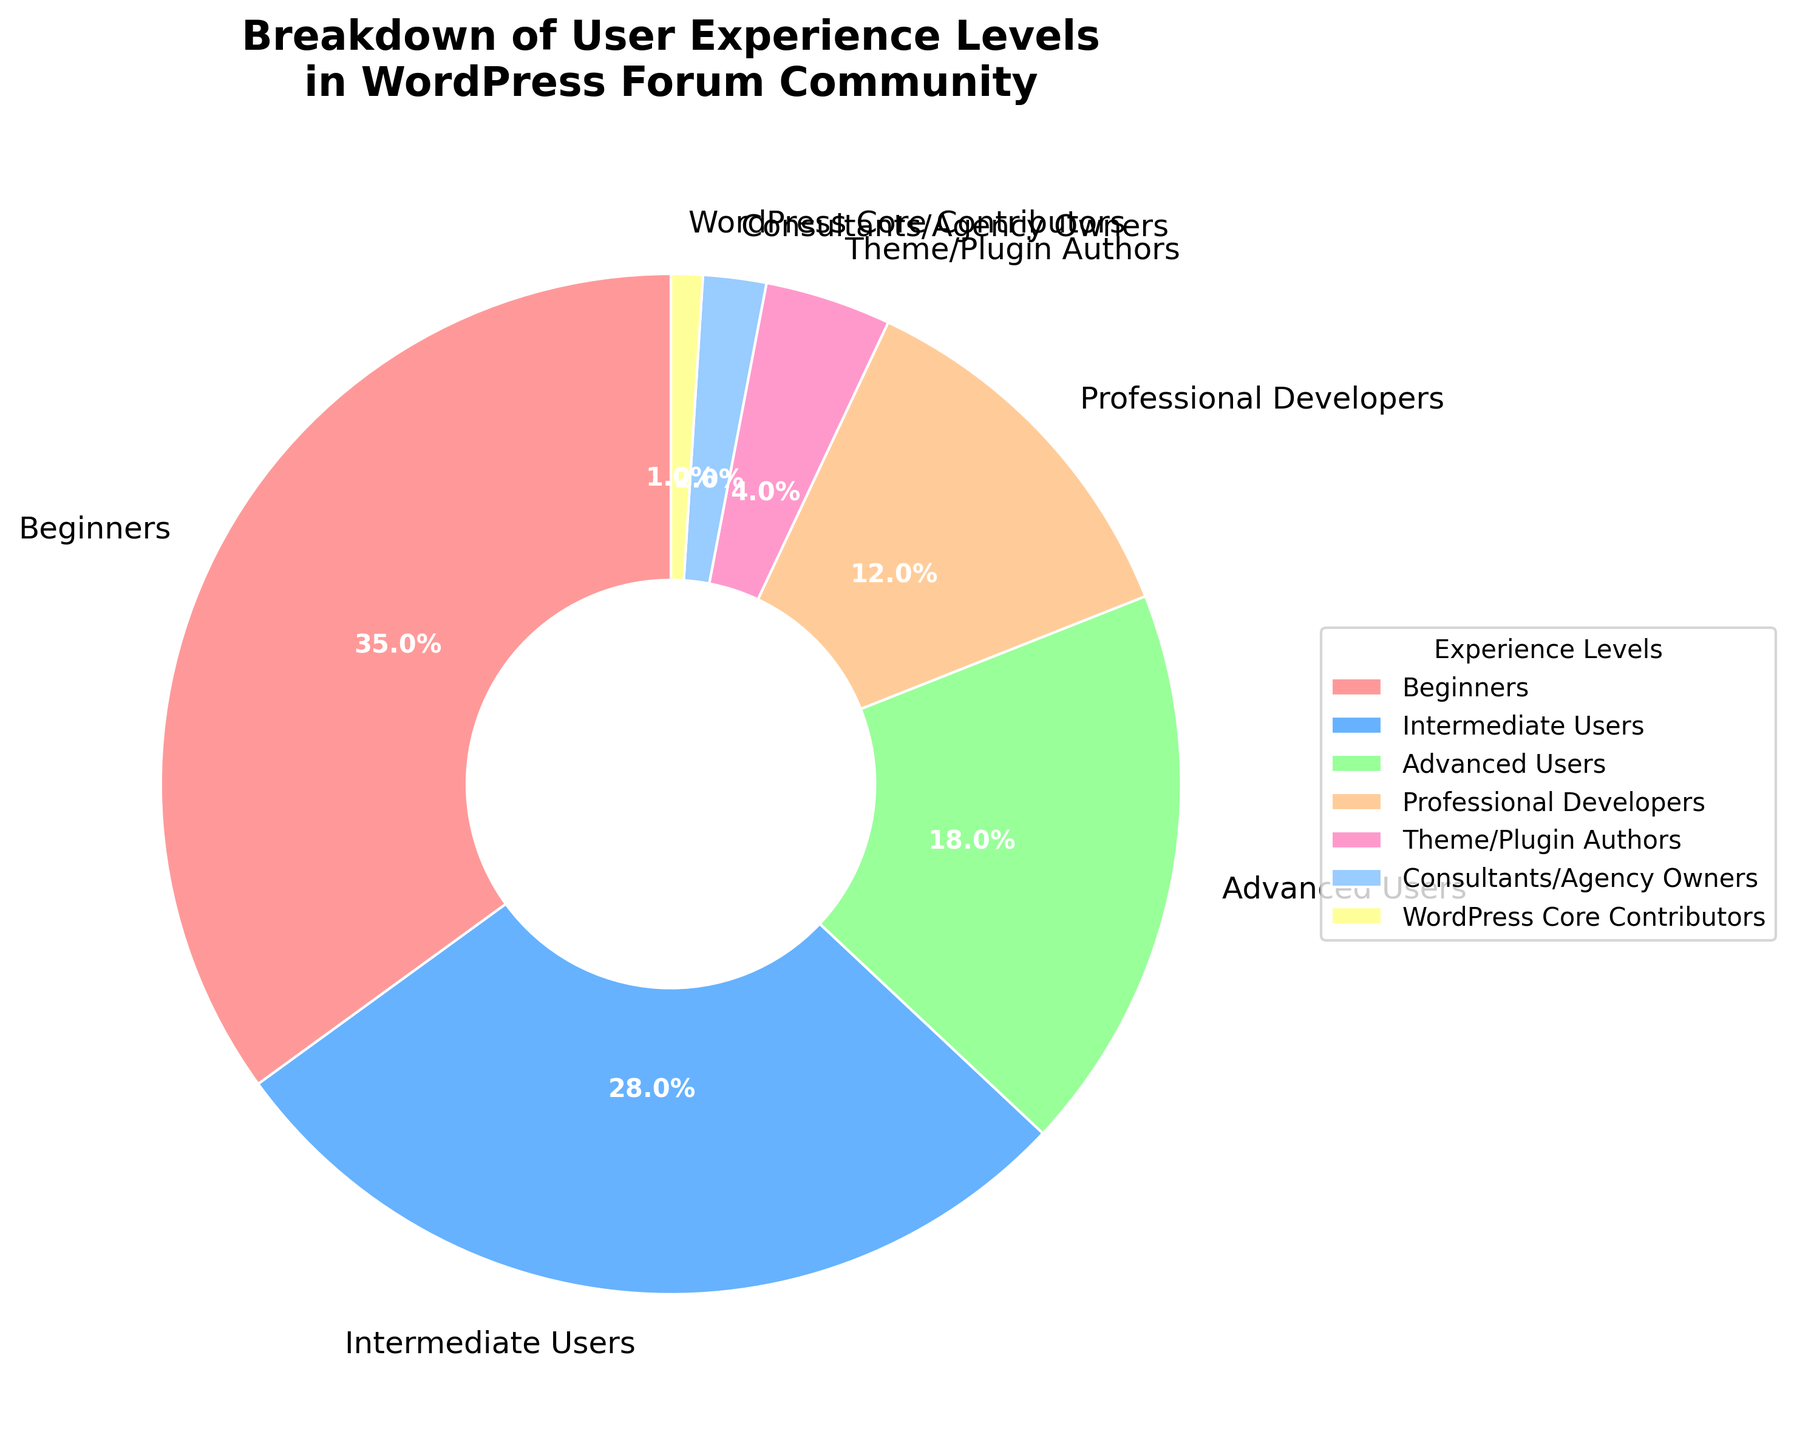What's the most common experience level in the WordPress forum community? The largest portion of the pie chart visually indicates the most common experience level, which is labeled "Beginners" with a 35% share.
Answer: Beginners Which experience level has the smallest percentage in the WordPress forum community? The smallest portion of the pie chart indicates the least common experience level, which is labeled "WordPress Core Contributors" with a 1% share.
Answer: WordPress Core Contributors How much more percentage do beginners make up compared to intermediate users? Beginners make up 35%, and intermediate users make up 28%. The difference between these percentages is calculated as 35% - 28% = 7%.
Answer: 7% Are there more advanced users or professional developers? By comparing the sizes of the respective sections, advanced users make up 18%, while professional developers make up 12%. Therefore, there are more advanced users.
Answer: Advanced Users What is the combined percentage of Consultants/Agency Owners and WordPress Core Contributors? Consultants/Agency Owners make up 2%, and WordPress Core Contributors make up 1%. The combined percentage is calculated as 2% + 1% = 3%.
Answer: 3% How does the percentage of theme/plugin authors compare to professional developers? Theme/Plugin Authors make up 4%, and professional developers make up 12%. Since 4% is less than 12%, there are fewer theme/plugin authors compared to professional developers.
Answer: Less What percentage of the community comprises users with intermediate to advanced experience levels (Intermediate Users + Advanced Users)? Intermediate Users make up 28%, and Advanced Users make up 18%. The combined percentage is calculated as 28% + 18% = 46%.
Answer: 46% Which color represents the largest segment of the pie chart? The largest segment of the pie chart, labeled "Beginners" with 35%, is represented by the color red.
Answer: Red What is the total percentage of the community that is made up of users beyond the beginner level? Users beyond the beginner level include Intermediate Users (28%), Advanced Users (18%), Professional Developers (12%), Theme/Plugin Authors (4%), Consultants/Agency Owners (2%), and WordPress Core Contributors (1%). The total percentage is 28% + 18% + 12% + 4% + 2% + 1% = 65%.
Answer: 65% If we combine the percentages of professional developers and theme/plugin authors, do they collectively make up more than the advanced users? Professional Developers make up 12%, and Theme/Plugin Authors make up 4%. The combined percentage is 12% + 4% = 16%. Since Advanced Users make up 18%, the combined percentage of professional developers and theme/plugin authors is less than that of advanced users.
Answer: No 